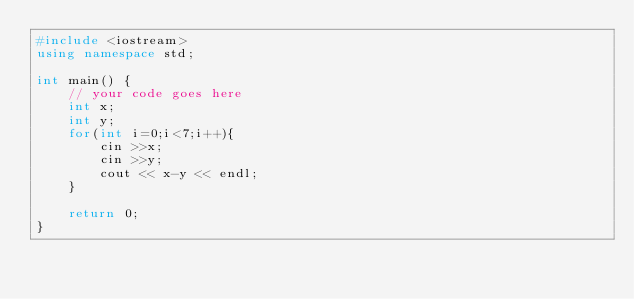<code> <loc_0><loc_0><loc_500><loc_500><_C++_>#include <iostream>
using namespace std;

int main() {
	// your code goes here
	int x; 
	int y;
	for(int i=0;i<7;i++){
		cin >>x;
		cin >>y;
 		cout << x-y << endl;
	}
	
	return 0;
}</code> 